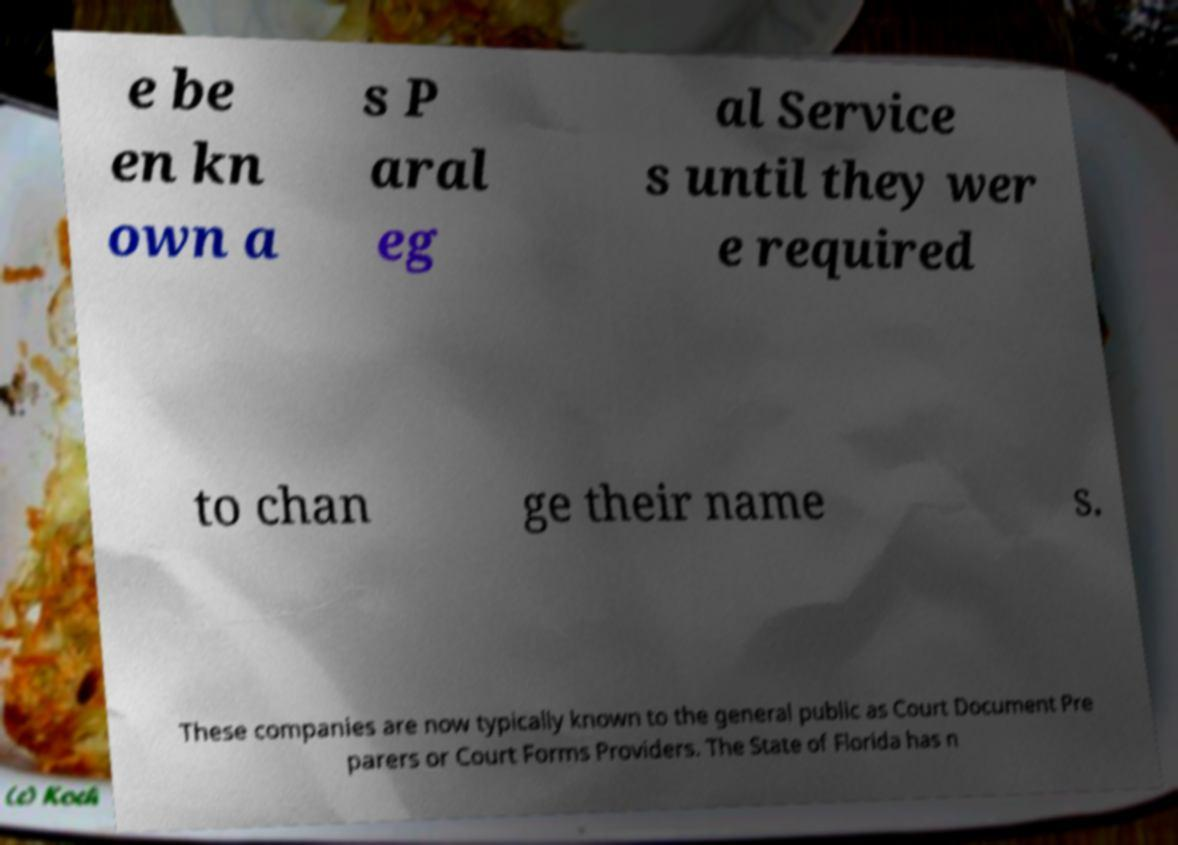What messages or text are displayed in this image? I need them in a readable, typed format. e be en kn own a s P aral eg al Service s until they wer e required to chan ge their name s. These companies are now typically known to the general public as Court Document Pre parers or Court Forms Providers. The State of Florida has n 